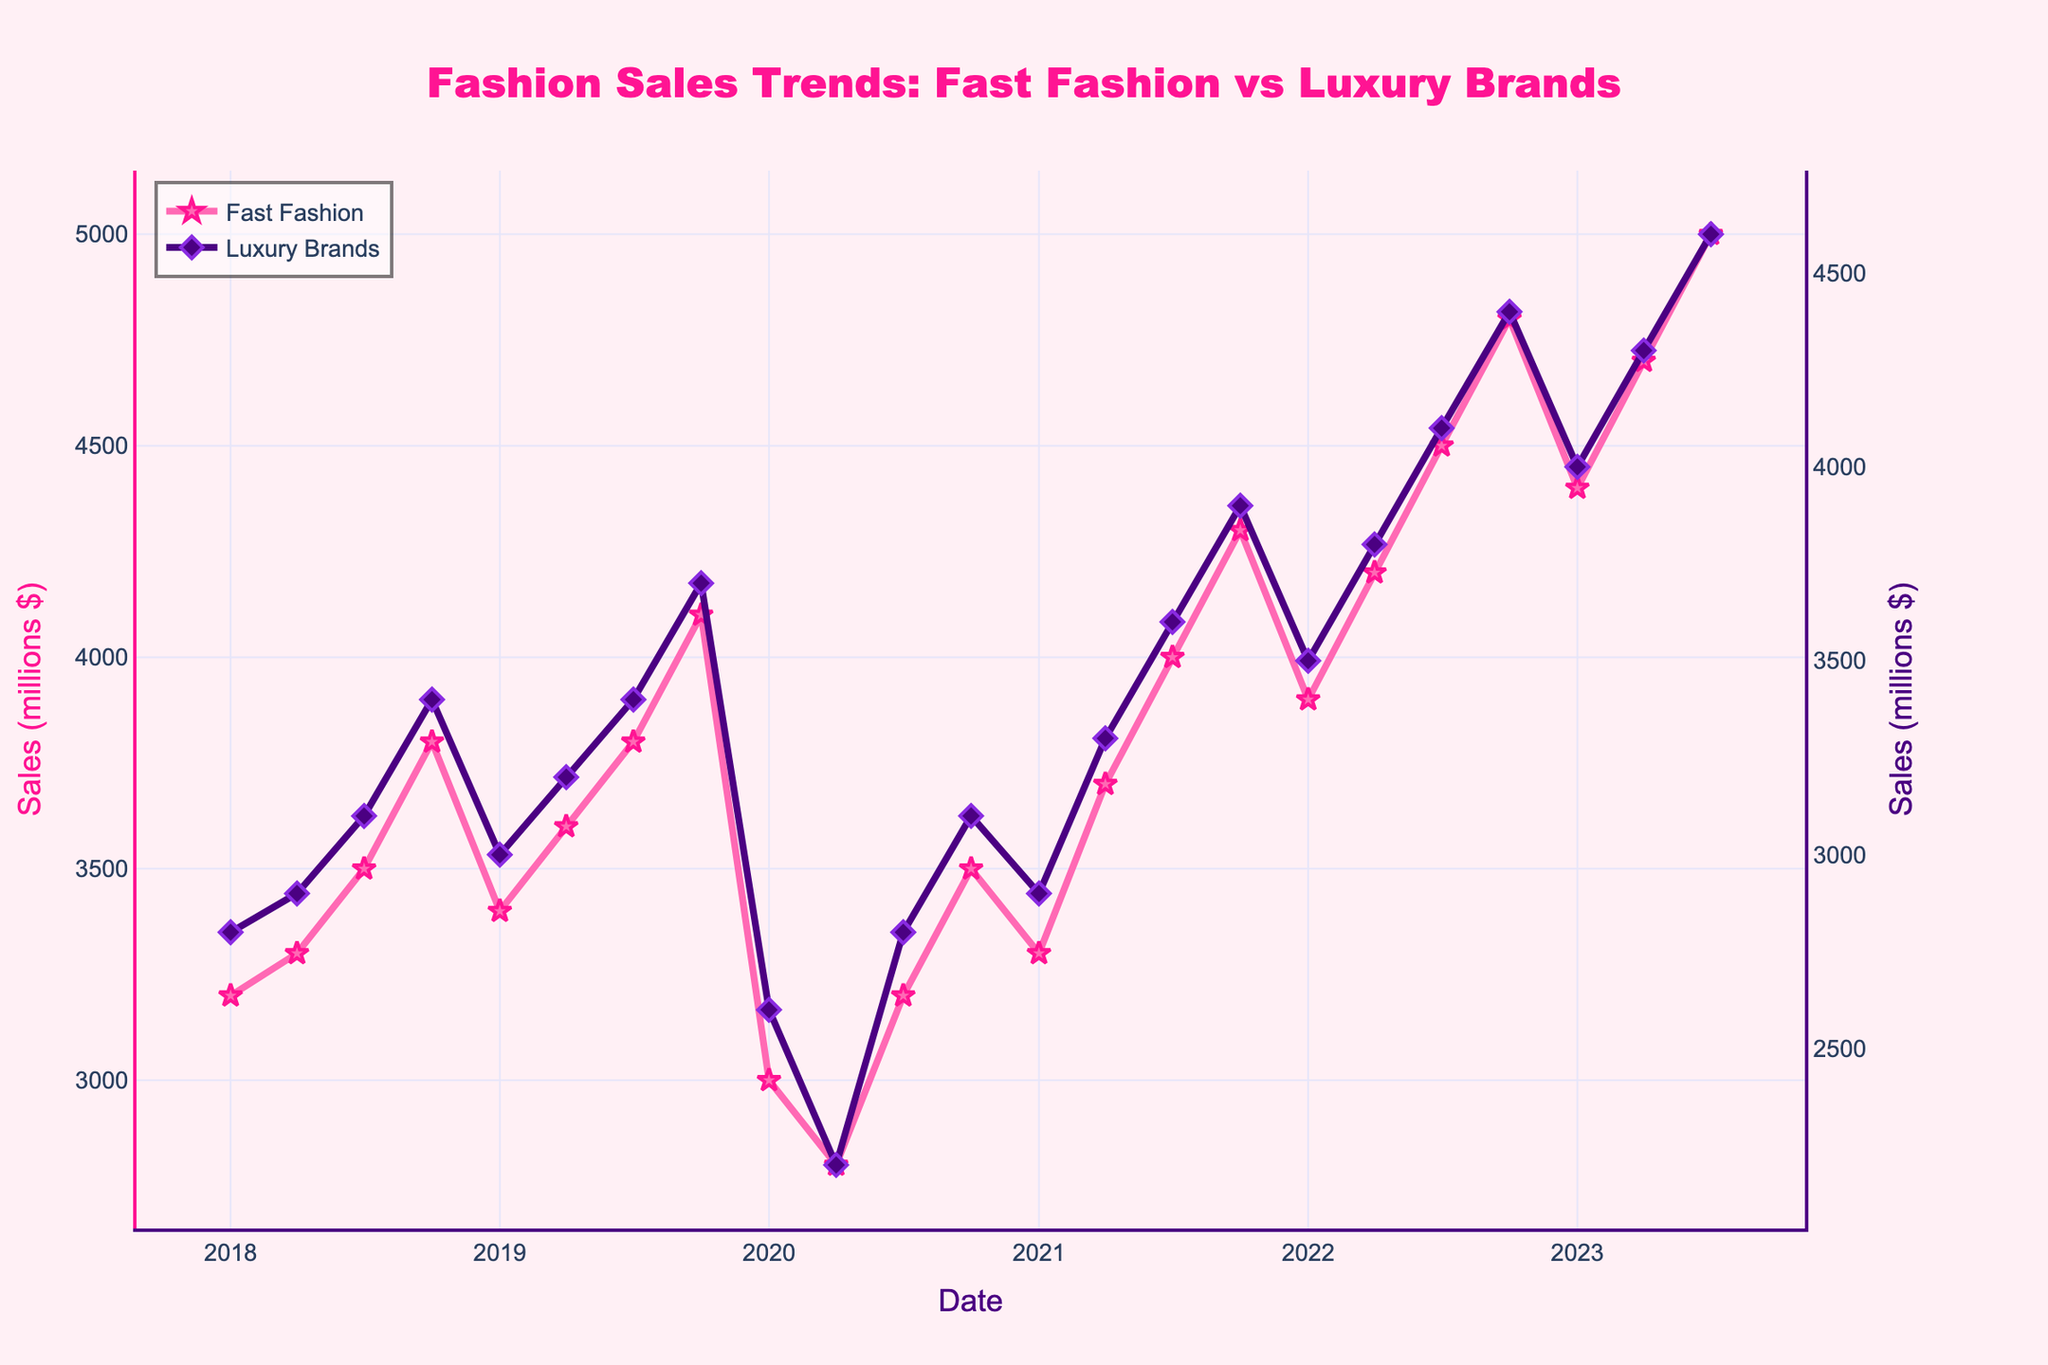What is the trend in Fast Fashion sales from 2018 to 2023? To find the trend, look at the general direction of the line representing Fast Fashion sales. From 2018 to 2023, the line generally slopes upwards, indicating an increase in sales over the years, with some dips in 2020.
Answer: Increasing with fluctuations in 2020 How do Luxury Brand sales in 2020 compare to 2019 and 2021? Compare the sales in 2020 with 2019 and 2021 by looking at the respective points on the chart. In 2019, sales hover around 3000-3700 million dollars, but in 2020, they drop significantly to around 2200-3100 million dollars before recovering slightly in 2021 to 2900-3900 million dollars.
Answer: Higher in 2019 and 2021 than in 2020 Which month and year recorded the highest sales for Fast Fashion? Identify the highest point on the Fast Fashion sales line. The peak point is in July 2023 with sales reaching 5000 million dollars.
Answer: July 2023 What was the difference in sales between Fast Fashion and Luxury Brands in July 2022? Look at the sales figures for both categories in July 2022. Fast Fashion sales were 4500 million dollars, and Luxury Brands were 4100 million dollars, so the difference is 4500 - 4100 = 400 million dollars.
Answer: 400 million dollars What are the visual differences between the Fast Fashion and Luxury Brand sales lines? Examine the color, markers, and thickness of the lines. Fast Fashion has a pink line with star markers, whereas Luxury Brand has a indigo line with diamond markers. Both lines are thick, but the marker shapes and colors distinguish them visually.
Answer: Pink star markers for Fast Fashion, indigo diamond markers for Luxury Brands What is the average annual sales growth for Fast Fashion from 2018 to 2023? Calculate yearly gains and average them. Fast Fashion sales increased from 3200 million in January 2018 to 5000 million in July 2023, a period covering 5.5 years. Annual growth is approximately (5000-3200)/5.5 ≈ 327.27 million per year.
Answer: Approximately 327.27 million per year During which years did both Fast Fashion and Luxury Brands show a sharp decline in sales? Identify periods where both lines show a steep drop. From early 2019 into early 2020, both lines dip notably. This corresponds with the global pandemic.
Answer: Early 2019-mid 2020 What can be inferred about the competitiveness between Fast Fashion and Luxury Brands over the years? Compare the proximity and overlap of the two lines over the time period. Fast Fashion sales generally exceed Luxury Brands, with the gap widening in recent years, suggesting Fast Fashion might be gaining a competitive edge.
Answer: Fast Fashion is gaining a competitive edge How did the sales of Fast Fashion and Luxury Brands recover post-2020? Observe the trend lines post-2020. Both Fast Fashion and Luxury Brands show a recovery, notably from 2021, with sales returning to an upward trend.
Answer: Both recovered and followed an upward trend What month consistently shows high sales figures for both Fast Fashion and Luxury Brands? Look for recurring peaks in the lines for each year. October frequently shows high sales for both brands, with noticeable peaks.
Answer: October 